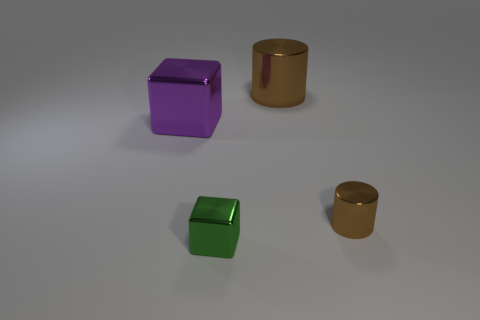Add 2 large purple metal objects. How many objects exist? 6 Subtract 0 gray cubes. How many objects are left? 4 Subtract all big brown things. Subtract all green cubes. How many objects are left? 2 Add 1 tiny metal objects. How many tiny metal objects are left? 3 Add 4 metal cylinders. How many metal cylinders exist? 6 